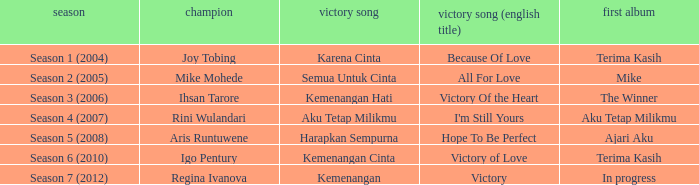Which winning song had a debut album in progress? Kemenangan. 